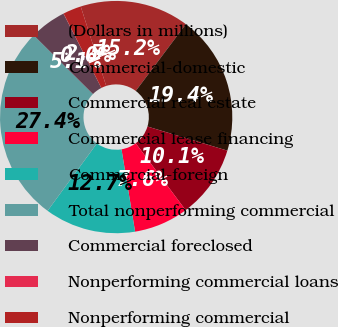Convert chart to OTSL. <chart><loc_0><loc_0><loc_500><loc_500><pie_chart><fcel>(Dollars in millions)<fcel>Commercial-domestic<fcel>Commercial real estate<fcel>Commercial lease financing<fcel>Commercial-foreign<fcel>Total nonperforming commercial<fcel>Commercial foreclosed<fcel>Nonperforming commercial loans<fcel>Nonperforming commercial<nl><fcel>15.18%<fcel>19.42%<fcel>10.13%<fcel>7.6%<fcel>12.66%<fcel>27.38%<fcel>5.07%<fcel>0.02%<fcel>2.54%<nl></chart> 